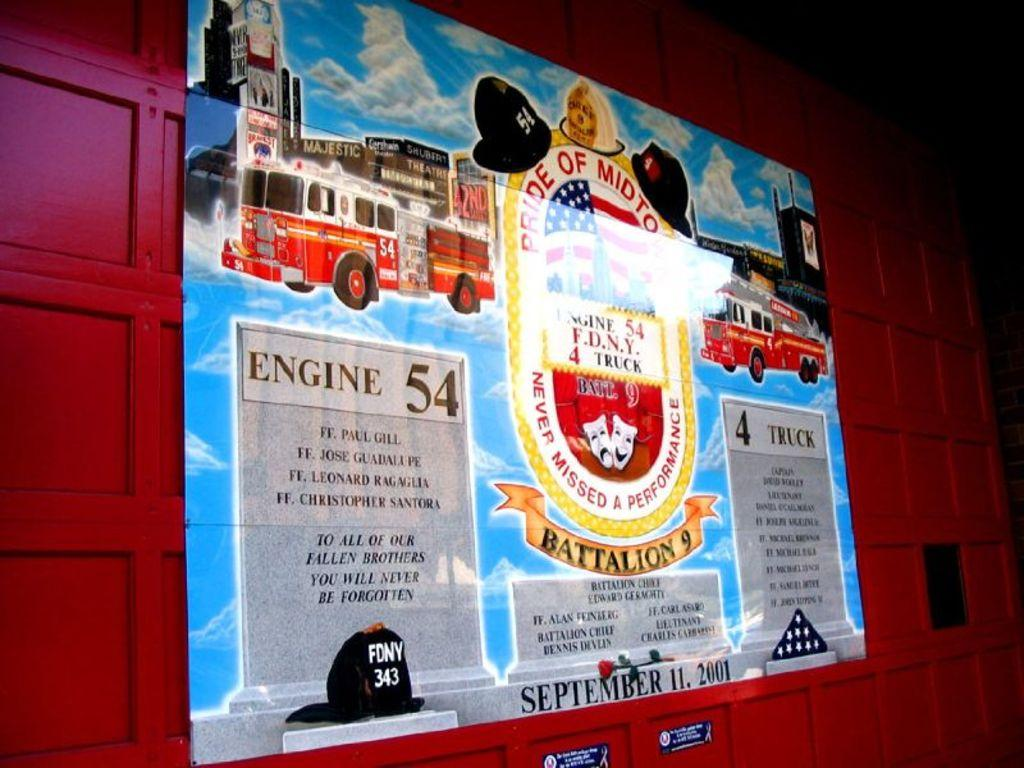Provide a one-sentence caption for the provided image. a poster on a wall that says 'engine 54' on it. 